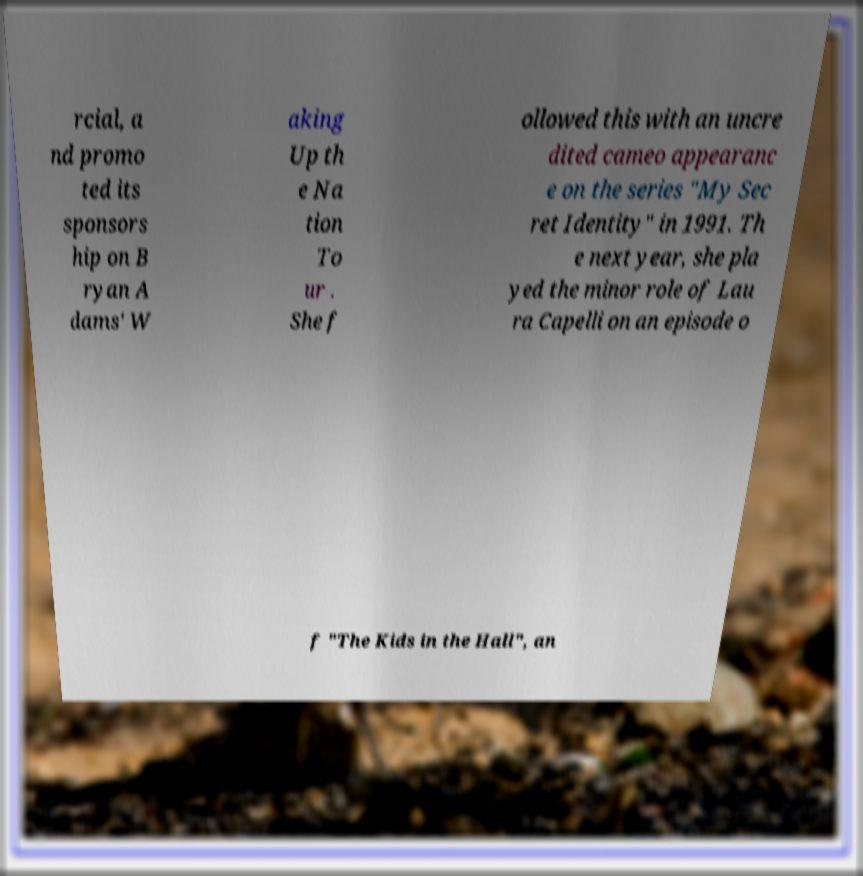For documentation purposes, I need the text within this image transcribed. Could you provide that? rcial, a nd promo ted its sponsors hip on B ryan A dams' W aking Up th e Na tion To ur . She f ollowed this with an uncre dited cameo appearanc e on the series "My Sec ret Identity" in 1991. Th e next year, she pla yed the minor role of Lau ra Capelli on an episode o f "The Kids in the Hall", an 